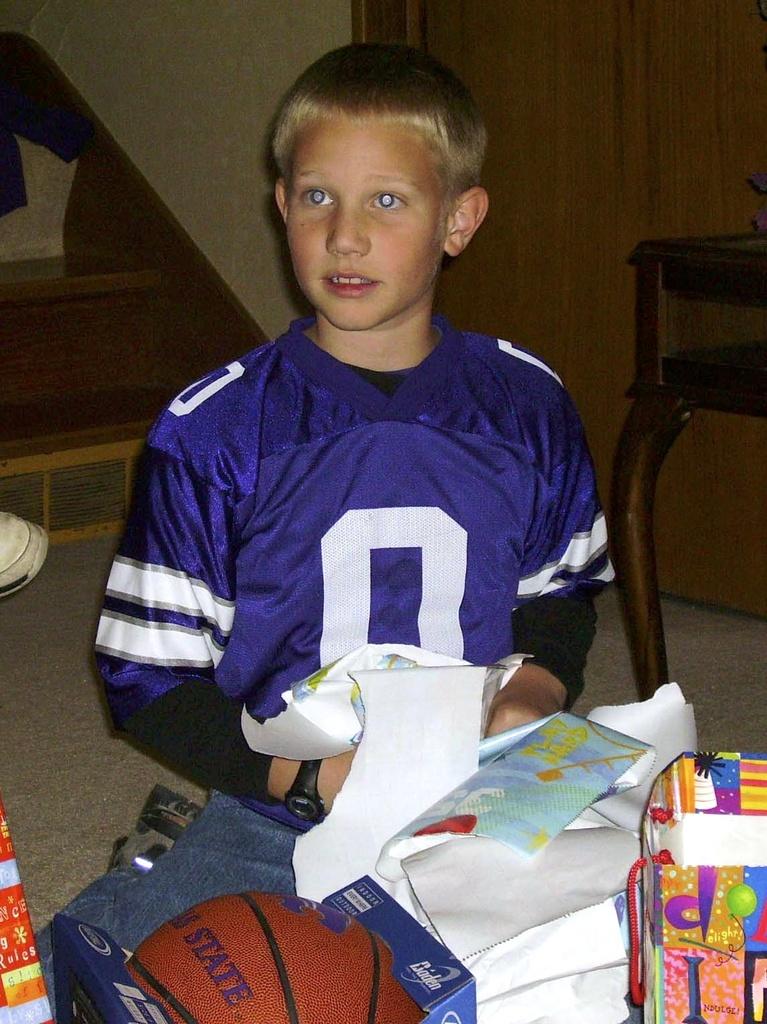What is the jersey number?
Offer a terse response. 0. 